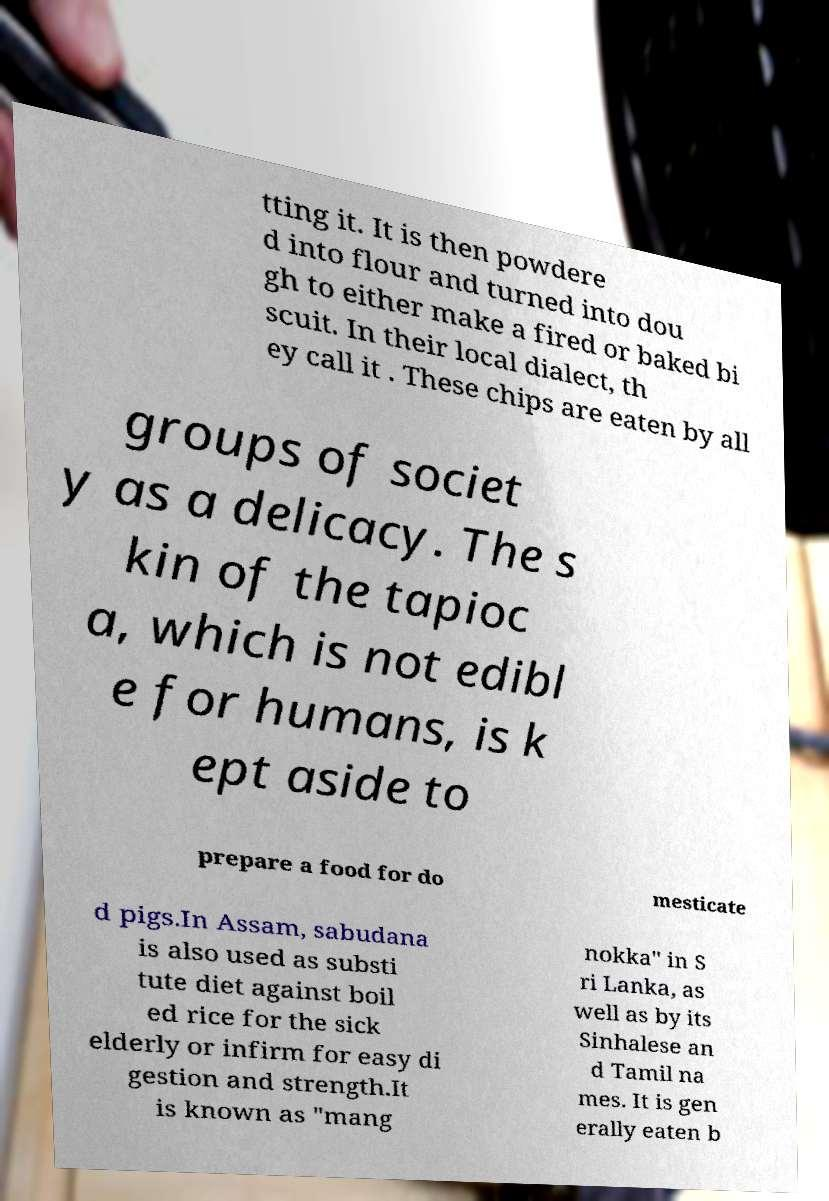Can you accurately transcribe the text from the provided image for me? tting it. It is then powdere d into flour and turned into dou gh to either make a fired or baked bi scuit. In their local dialect, th ey call it . These chips are eaten by all groups of societ y as a delicacy. The s kin of the tapioc a, which is not edibl e for humans, is k ept aside to prepare a food for do mesticate d pigs.In Assam, sabudana is also used as substi tute diet against boil ed rice for the sick elderly or infirm for easy di gestion and strength.It is known as "mang nokka" in S ri Lanka, as well as by its Sinhalese an d Tamil na mes. It is gen erally eaten b 